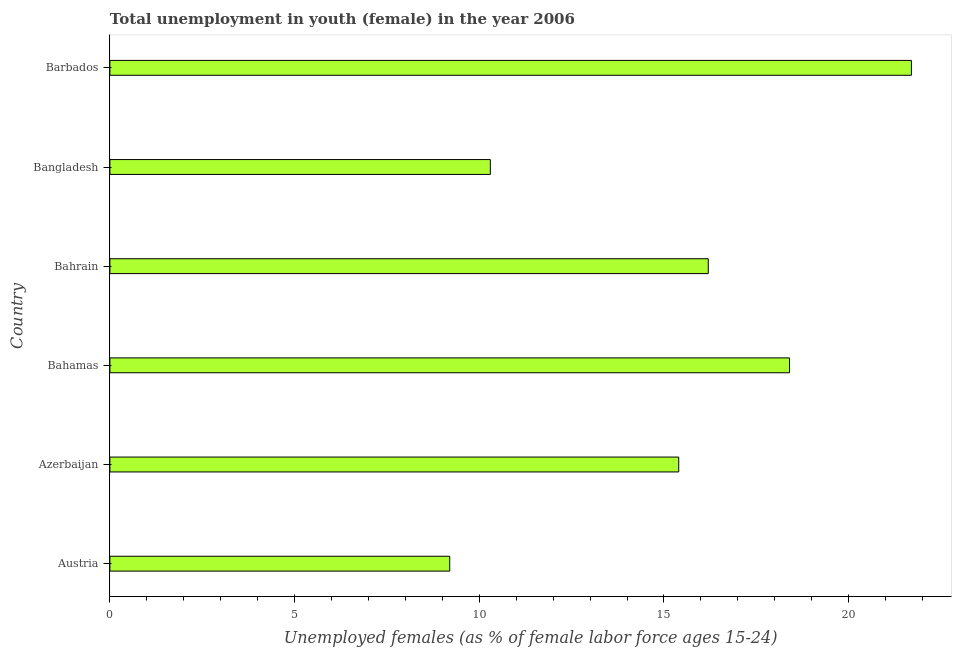Does the graph contain any zero values?
Provide a succinct answer. No. Does the graph contain grids?
Provide a short and direct response. No. What is the title of the graph?
Provide a succinct answer. Total unemployment in youth (female) in the year 2006. What is the label or title of the X-axis?
Your answer should be compact. Unemployed females (as % of female labor force ages 15-24). What is the unemployed female youth population in Bangladesh?
Provide a succinct answer. 10.3. Across all countries, what is the maximum unemployed female youth population?
Provide a succinct answer. 21.7. Across all countries, what is the minimum unemployed female youth population?
Provide a succinct answer. 9.2. In which country was the unemployed female youth population maximum?
Provide a succinct answer. Barbados. What is the sum of the unemployed female youth population?
Offer a terse response. 91.2. What is the median unemployed female youth population?
Your response must be concise. 15.8. In how many countries, is the unemployed female youth population greater than 12 %?
Keep it short and to the point. 4. What is the ratio of the unemployed female youth population in Bahrain to that in Bangladesh?
Keep it short and to the point. 1.57. Is the unemployed female youth population in Bahrain less than that in Barbados?
Make the answer very short. Yes. Is the difference between the unemployed female youth population in Azerbaijan and Barbados greater than the difference between any two countries?
Make the answer very short. No. What is the difference between the highest and the second highest unemployed female youth population?
Keep it short and to the point. 3.3. Is the sum of the unemployed female youth population in Bahrain and Bangladesh greater than the maximum unemployed female youth population across all countries?
Your answer should be very brief. Yes. What is the difference between the highest and the lowest unemployed female youth population?
Give a very brief answer. 12.5. In how many countries, is the unemployed female youth population greater than the average unemployed female youth population taken over all countries?
Provide a succinct answer. 4. How many countries are there in the graph?
Offer a very short reply. 6. What is the difference between two consecutive major ticks on the X-axis?
Provide a short and direct response. 5. Are the values on the major ticks of X-axis written in scientific E-notation?
Keep it short and to the point. No. What is the Unemployed females (as % of female labor force ages 15-24) of Austria?
Ensure brevity in your answer.  9.2. What is the Unemployed females (as % of female labor force ages 15-24) of Azerbaijan?
Provide a short and direct response. 15.4. What is the Unemployed females (as % of female labor force ages 15-24) in Bahamas?
Your response must be concise. 18.4. What is the Unemployed females (as % of female labor force ages 15-24) of Bahrain?
Your response must be concise. 16.2. What is the Unemployed females (as % of female labor force ages 15-24) in Bangladesh?
Keep it short and to the point. 10.3. What is the Unemployed females (as % of female labor force ages 15-24) in Barbados?
Keep it short and to the point. 21.7. What is the difference between the Unemployed females (as % of female labor force ages 15-24) in Austria and Azerbaijan?
Provide a succinct answer. -6.2. What is the difference between the Unemployed females (as % of female labor force ages 15-24) in Azerbaijan and Bahamas?
Ensure brevity in your answer.  -3. What is the difference between the Unemployed females (as % of female labor force ages 15-24) in Azerbaijan and Bangladesh?
Keep it short and to the point. 5.1. What is the difference between the Unemployed females (as % of female labor force ages 15-24) in Azerbaijan and Barbados?
Give a very brief answer. -6.3. What is the difference between the Unemployed females (as % of female labor force ages 15-24) in Bahamas and Bahrain?
Provide a succinct answer. 2.2. What is the difference between the Unemployed females (as % of female labor force ages 15-24) in Bahamas and Barbados?
Offer a terse response. -3.3. What is the difference between the Unemployed females (as % of female labor force ages 15-24) in Bahrain and Bangladesh?
Ensure brevity in your answer.  5.9. What is the ratio of the Unemployed females (as % of female labor force ages 15-24) in Austria to that in Azerbaijan?
Provide a succinct answer. 0.6. What is the ratio of the Unemployed females (as % of female labor force ages 15-24) in Austria to that in Bahrain?
Provide a short and direct response. 0.57. What is the ratio of the Unemployed females (as % of female labor force ages 15-24) in Austria to that in Bangladesh?
Keep it short and to the point. 0.89. What is the ratio of the Unemployed females (as % of female labor force ages 15-24) in Austria to that in Barbados?
Your answer should be compact. 0.42. What is the ratio of the Unemployed females (as % of female labor force ages 15-24) in Azerbaijan to that in Bahamas?
Keep it short and to the point. 0.84. What is the ratio of the Unemployed females (as % of female labor force ages 15-24) in Azerbaijan to that in Bahrain?
Keep it short and to the point. 0.95. What is the ratio of the Unemployed females (as % of female labor force ages 15-24) in Azerbaijan to that in Bangladesh?
Give a very brief answer. 1.5. What is the ratio of the Unemployed females (as % of female labor force ages 15-24) in Azerbaijan to that in Barbados?
Give a very brief answer. 0.71. What is the ratio of the Unemployed females (as % of female labor force ages 15-24) in Bahamas to that in Bahrain?
Keep it short and to the point. 1.14. What is the ratio of the Unemployed females (as % of female labor force ages 15-24) in Bahamas to that in Bangladesh?
Your answer should be very brief. 1.79. What is the ratio of the Unemployed females (as % of female labor force ages 15-24) in Bahamas to that in Barbados?
Keep it short and to the point. 0.85. What is the ratio of the Unemployed females (as % of female labor force ages 15-24) in Bahrain to that in Bangladesh?
Offer a very short reply. 1.57. What is the ratio of the Unemployed females (as % of female labor force ages 15-24) in Bahrain to that in Barbados?
Your answer should be very brief. 0.75. What is the ratio of the Unemployed females (as % of female labor force ages 15-24) in Bangladesh to that in Barbados?
Ensure brevity in your answer.  0.47. 